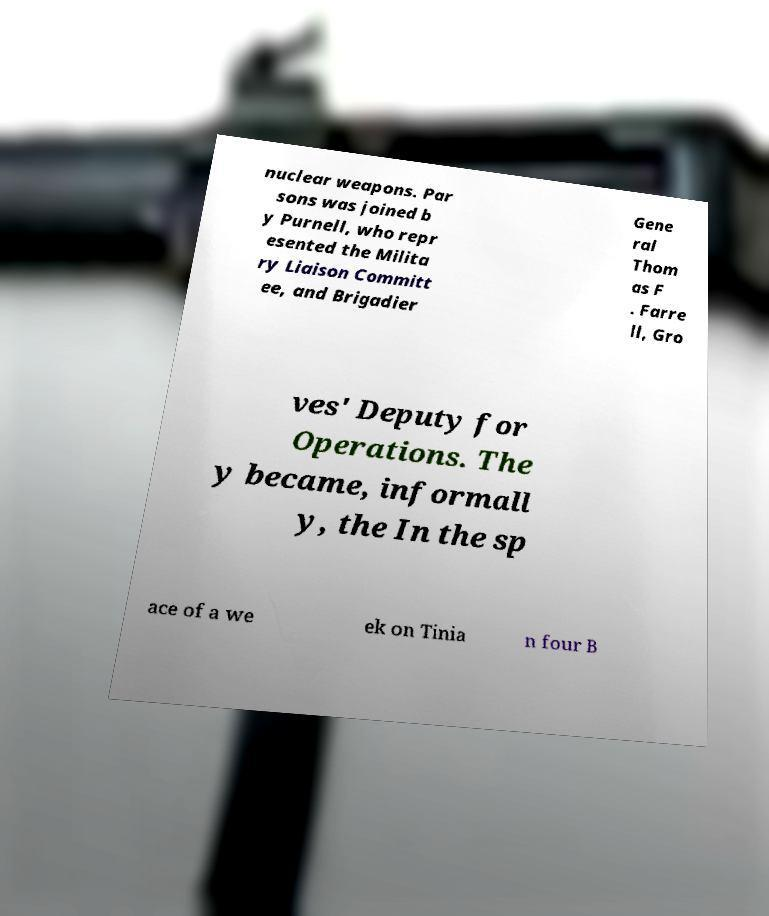What messages or text are displayed in this image? I need them in a readable, typed format. nuclear weapons. Par sons was joined b y Purnell, who repr esented the Milita ry Liaison Committ ee, and Brigadier Gene ral Thom as F . Farre ll, Gro ves' Deputy for Operations. The y became, informall y, the In the sp ace of a we ek on Tinia n four B 